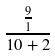<formula> <loc_0><loc_0><loc_500><loc_500>\frac { \frac { 9 } { 1 } } { 1 0 + 2 }</formula> 